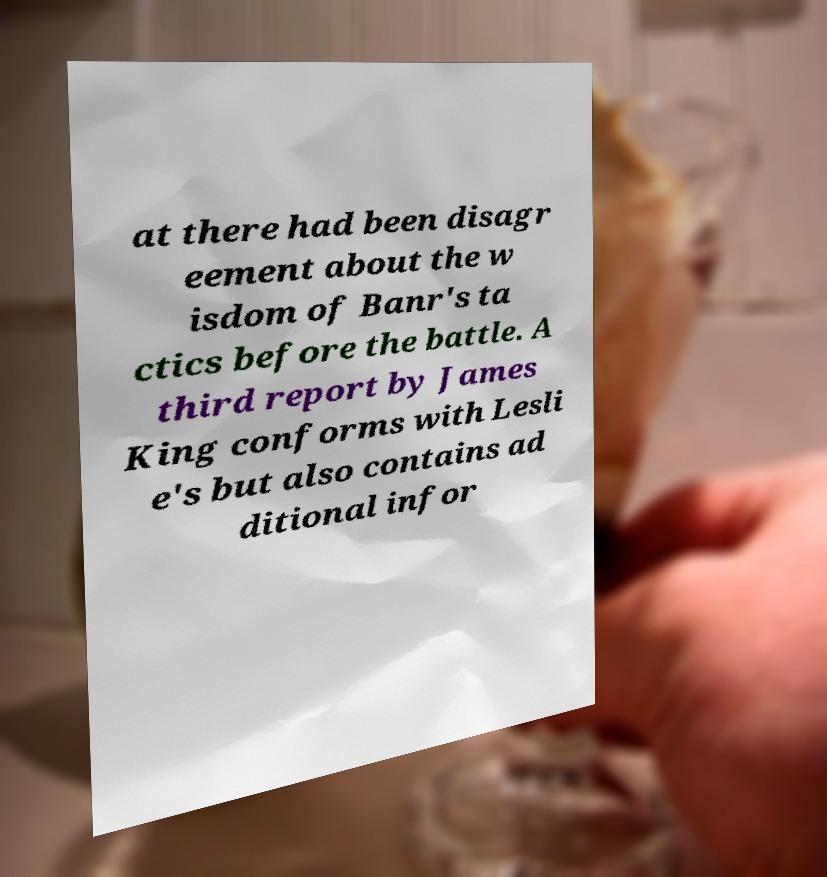Could you assist in decoding the text presented in this image and type it out clearly? at there had been disagr eement about the w isdom of Banr's ta ctics before the battle. A third report by James King conforms with Lesli e's but also contains ad ditional infor 